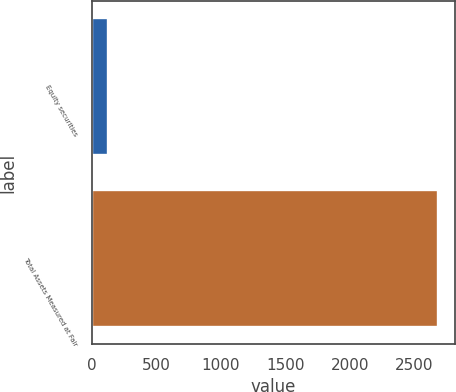Convert chart. <chart><loc_0><loc_0><loc_500><loc_500><bar_chart><fcel>Equity securities<fcel>Total Assets Measured at Fair<nl><fcel>128.1<fcel>2683.3<nl></chart> 